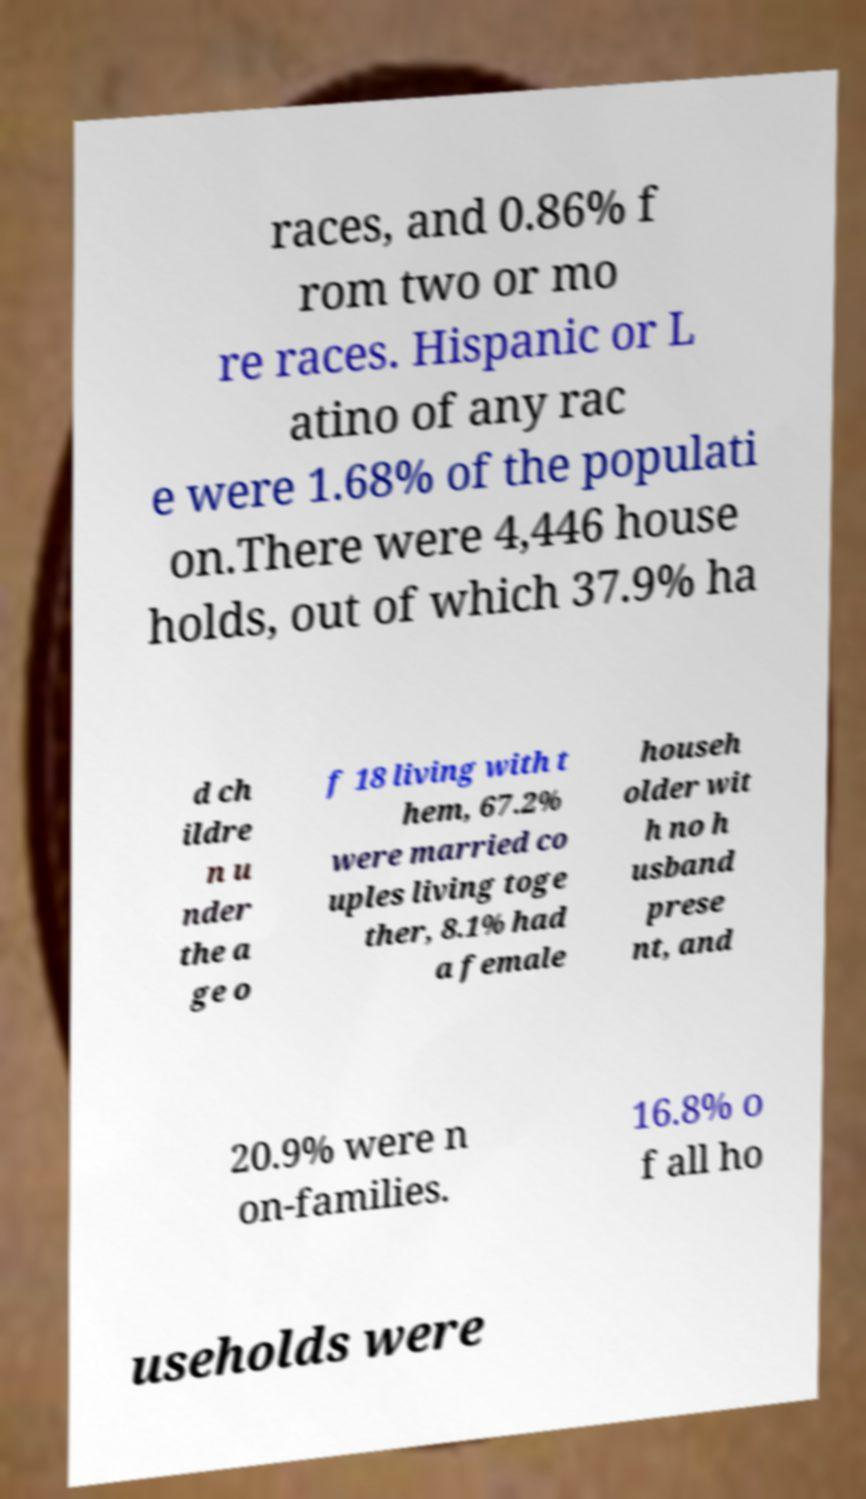I need the written content from this picture converted into text. Can you do that? races, and 0.86% f rom two or mo re races. Hispanic or L atino of any rac e were 1.68% of the populati on.There were 4,446 house holds, out of which 37.9% ha d ch ildre n u nder the a ge o f 18 living with t hem, 67.2% were married co uples living toge ther, 8.1% had a female househ older wit h no h usband prese nt, and 20.9% were n on-families. 16.8% o f all ho useholds were 